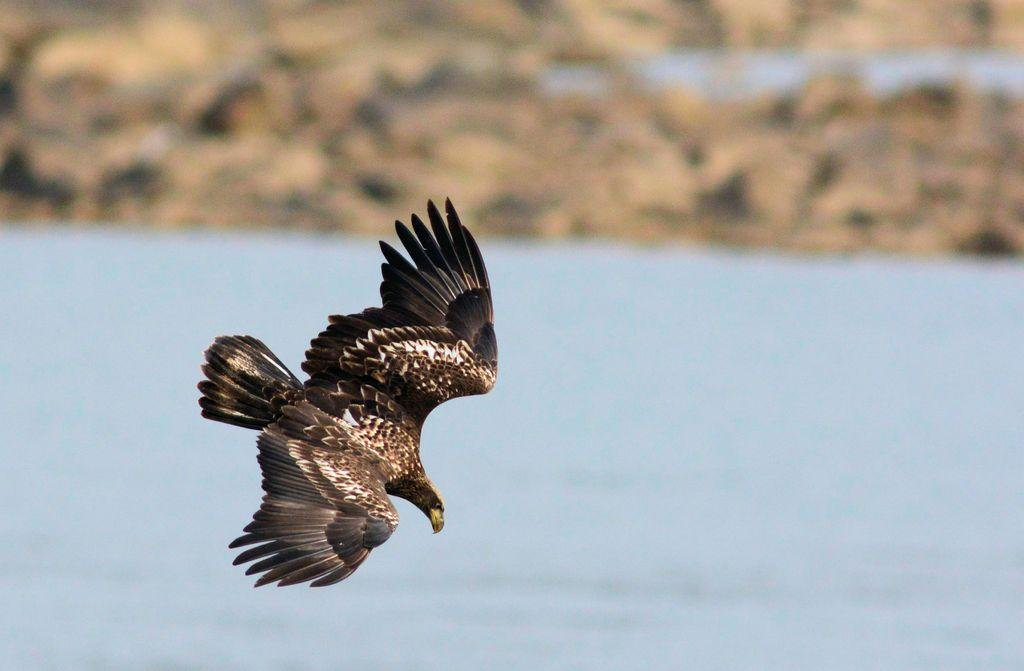What animal is featured in the image? There is an eagle in the image. What is the eagle doing in the image? The eagle is flying in the air. What can be seen at the bottom of the image? There is water visible at the bottom of the image. What is visible at the top of the image? The ground is visible at the top of the image. How would you describe the background of the image? The background of the image is blurry. Where is the shoe located in the image? There is no shoe present in the image. What type of mitten is the eagle holding in the image? There is no mitten present in the image, and the eagle is not holding anything. 